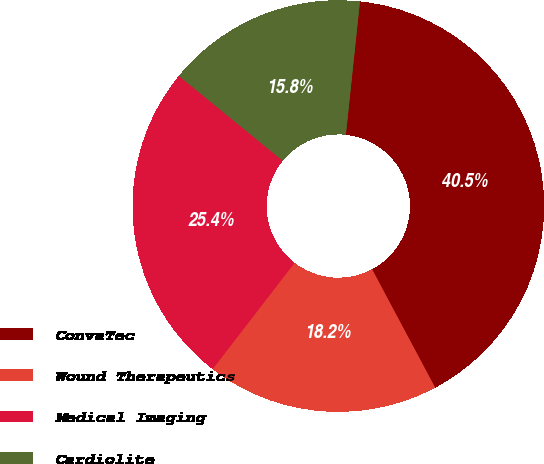Convert chart to OTSL. <chart><loc_0><loc_0><loc_500><loc_500><pie_chart><fcel>ConvaTec<fcel>Wound Therapeutics<fcel>Medical Imaging<fcel>Cardiolite<nl><fcel>40.53%<fcel>18.25%<fcel>25.44%<fcel>15.78%<nl></chart> 